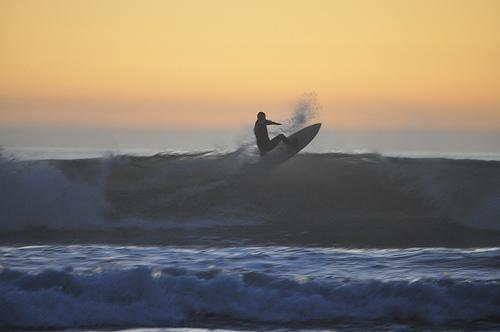Question: when was this photo taken?
Choices:
A. At 7 am.
B. Last night.
C. In the evening.
D. In the dark.
Answer with the letter. Answer: C Question: why is the man on a board?
Choices:
A. He is painting.
B. Balancing for fun.
C. He is surfing.
D. Skating.
Answer with the letter. Answer: C Question: who is the subject of the photo?
Choices:
A. Your mother.
B. The office manager.
C. The surfer.
D. Paris Hilton.
Answer with the letter. Answer: C Question: where is the man?
Choices:
A. On the bench.
B. On the surfboard.
C. On the boat.
D. On the bike.
Answer with the letter. Answer: B 